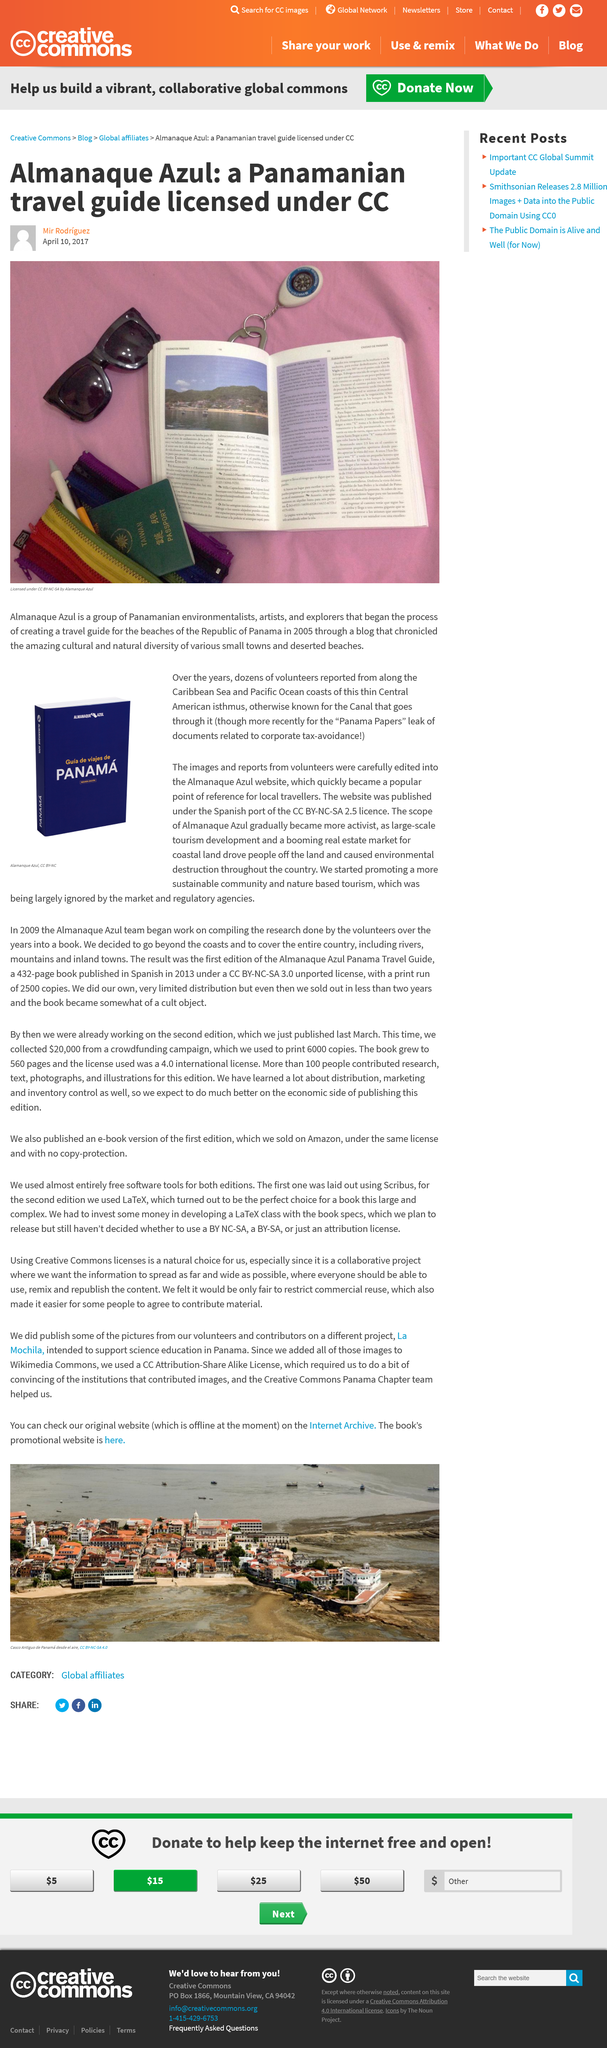Indicate a few pertinent items in this graphic. This photo is licensed by Almanaque Azul, a group that discusses the picture. Almanaque Azul is a collective of Panamanian environmentalists, artists, and explorers who are in the process of developing a travel guide for the beaches of the Republic of Panama. This group was created in the year 2005. 